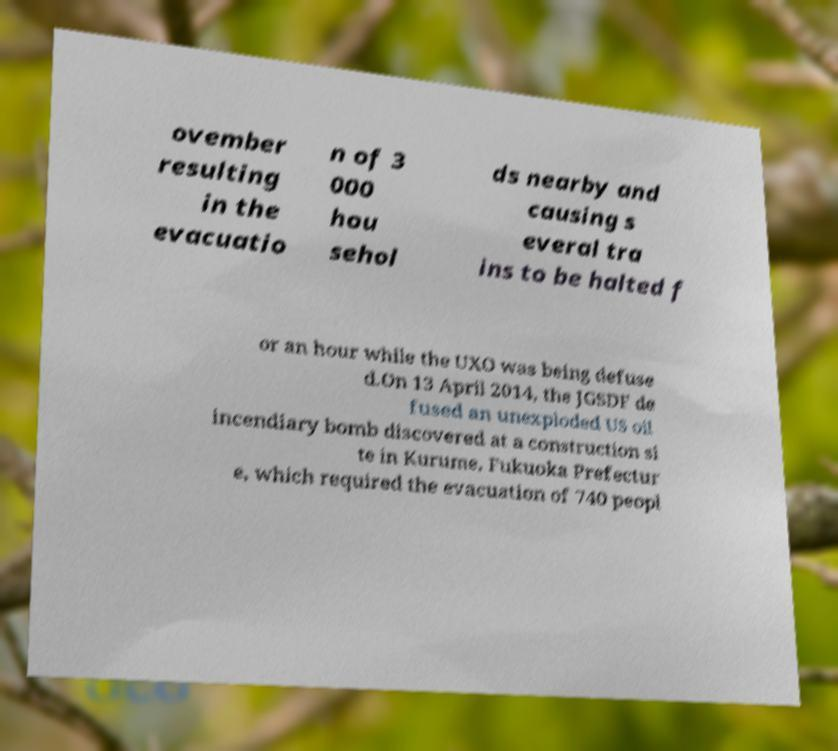There's text embedded in this image that I need extracted. Can you transcribe it verbatim? ovember resulting in the evacuatio n of 3 000 hou sehol ds nearby and causing s everal tra ins to be halted f or an hour while the UXO was being defuse d.On 13 April 2014, the JGSDF de fused an unexploded US oil incendiary bomb discovered at a construction si te in Kurume, Fukuoka Prefectur e, which required the evacuation of 740 peopl 